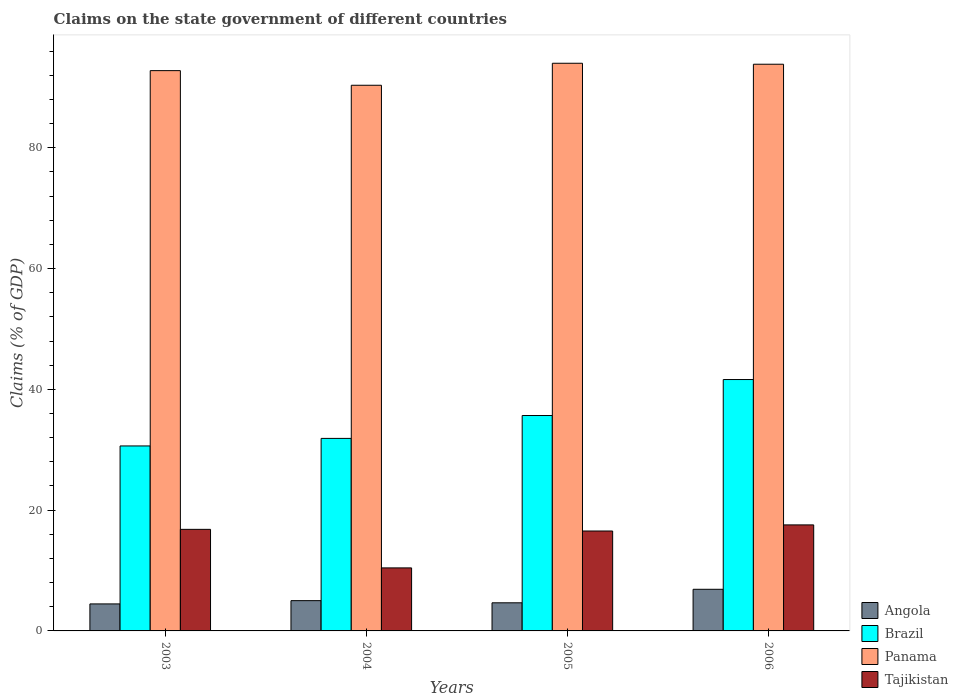Are the number of bars per tick equal to the number of legend labels?
Your response must be concise. Yes. Are the number of bars on each tick of the X-axis equal?
Give a very brief answer. Yes. In how many cases, is the number of bars for a given year not equal to the number of legend labels?
Give a very brief answer. 0. What is the percentage of GDP claimed on the state government in Panama in 2004?
Your answer should be very brief. 90.35. Across all years, what is the maximum percentage of GDP claimed on the state government in Brazil?
Provide a succinct answer. 41.63. Across all years, what is the minimum percentage of GDP claimed on the state government in Tajikistan?
Make the answer very short. 10.44. In which year was the percentage of GDP claimed on the state government in Angola maximum?
Offer a terse response. 2006. In which year was the percentage of GDP claimed on the state government in Panama minimum?
Provide a short and direct response. 2004. What is the total percentage of GDP claimed on the state government in Panama in the graph?
Your answer should be compact. 370.96. What is the difference between the percentage of GDP claimed on the state government in Tajikistan in 2003 and that in 2006?
Provide a succinct answer. -0.74. What is the difference between the percentage of GDP claimed on the state government in Brazil in 2006 and the percentage of GDP claimed on the state government in Angola in 2004?
Offer a very short reply. 36.61. What is the average percentage of GDP claimed on the state government in Panama per year?
Your response must be concise. 92.74. In the year 2003, what is the difference between the percentage of GDP claimed on the state government in Angola and percentage of GDP claimed on the state government in Brazil?
Provide a succinct answer. -26.16. In how many years, is the percentage of GDP claimed on the state government in Brazil greater than 76 %?
Offer a terse response. 0. What is the ratio of the percentage of GDP claimed on the state government in Brazil in 2004 to that in 2005?
Provide a short and direct response. 0.89. What is the difference between the highest and the second highest percentage of GDP claimed on the state government in Panama?
Your response must be concise. 0.16. What is the difference between the highest and the lowest percentage of GDP claimed on the state government in Panama?
Offer a very short reply. 3.64. In how many years, is the percentage of GDP claimed on the state government in Tajikistan greater than the average percentage of GDP claimed on the state government in Tajikistan taken over all years?
Provide a succinct answer. 3. Is it the case that in every year, the sum of the percentage of GDP claimed on the state government in Brazil and percentage of GDP claimed on the state government in Tajikistan is greater than the sum of percentage of GDP claimed on the state government in Panama and percentage of GDP claimed on the state government in Angola?
Your answer should be compact. No. What does the 3rd bar from the left in 2004 represents?
Your answer should be very brief. Panama. Are all the bars in the graph horizontal?
Your answer should be compact. No. Does the graph contain grids?
Make the answer very short. No. What is the title of the graph?
Give a very brief answer. Claims on the state government of different countries. What is the label or title of the Y-axis?
Your answer should be very brief. Claims (% of GDP). What is the Claims (% of GDP) of Angola in 2003?
Ensure brevity in your answer.  4.47. What is the Claims (% of GDP) in Brazil in 2003?
Make the answer very short. 30.63. What is the Claims (% of GDP) in Panama in 2003?
Your answer should be compact. 92.78. What is the Claims (% of GDP) in Tajikistan in 2003?
Your response must be concise. 16.82. What is the Claims (% of GDP) of Angola in 2004?
Your response must be concise. 5.01. What is the Claims (% of GDP) in Brazil in 2004?
Make the answer very short. 31.88. What is the Claims (% of GDP) in Panama in 2004?
Your answer should be very brief. 90.35. What is the Claims (% of GDP) of Tajikistan in 2004?
Provide a succinct answer. 10.44. What is the Claims (% of GDP) of Angola in 2005?
Give a very brief answer. 4.66. What is the Claims (% of GDP) of Brazil in 2005?
Offer a very short reply. 35.67. What is the Claims (% of GDP) in Panama in 2005?
Your response must be concise. 94. What is the Claims (% of GDP) of Tajikistan in 2005?
Ensure brevity in your answer.  16.54. What is the Claims (% of GDP) in Angola in 2006?
Your answer should be compact. 6.89. What is the Claims (% of GDP) of Brazil in 2006?
Provide a succinct answer. 41.63. What is the Claims (% of GDP) in Panama in 2006?
Offer a terse response. 93.84. What is the Claims (% of GDP) of Tajikistan in 2006?
Provide a short and direct response. 17.56. Across all years, what is the maximum Claims (% of GDP) in Angola?
Provide a succinct answer. 6.89. Across all years, what is the maximum Claims (% of GDP) in Brazil?
Offer a terse response. 41.63. Across all years, what is the maximum Claims (% of GDP) in Panama?
Your answer should be very brief. 94. Across all years, what is the maximum Claims (% of GDP) of Tajikistan?
Offer a terse response. 17.56. Across all years, what is the minimum Claims (% of GDP) in Angola?
Provide a short and direct response. 4.47. Across all years, what is the minimum Claims (% of GDP) of Brazil?
Offer a very short reply. 30.63. Across all years, what is the minimum Claims (% of GDP) of Panama?
Offer a terse response. 90.35. Across all years, what is the minimum Claims (% of GDP) of Tajikistan?
Make the answer very short. 10.44. What is the total Claims (% of GDP) of Angola in the graph?
Make the answer very short. 21.03. What is the total Claims (% of GDP) of Brazil in the graph?
Offer a terse response. 139.8. What is the total Claims (% of GDP) of Panama in the graph?
Offer a terse response. 370.96. What is the total Claims (% of GDP) of Tajikistan in the graph?
Make the answer very short. 61.35. What is the difference between the Claims (% of GDP) of Angola in 2003 and that in 2004?
Offer a very short reply. -0.54. What is the difference between the Claims (% of GDP) in Brazil in 2003 and that in 2004?
Offer a terse response. -1.25. What is the difference between the Claims (% of GDP) of Panama in 2003 and that in 2004?
Provide a succinct answer. 2.42. What is the difference between the Claims (% of GDP) of Tajikistan in 2003 and that in 2004?
Your response must be concise. 6.38. What is the difference between the Claims (% of GDP) of Angola in 2003 and that in 2005?
Your response must be concise. -0.18. What is the difference between the Claims (% of GDP) of Brazil in 2003 and that in 2005?
Your answer should be compact. -5.04. What is the difference between the Claims (% of GDP) in Panama in 2003 and that in 2005?
Make the answer very short. -1.22. What is the difference between the Claims (% of GDP) of Tajikistan in 2003 and that in 2005?
Give a very brief answer. 0.27. What is the difference between the Claims (% of GDP) in Angola in 2003 and that in 2006?
Give a very brief answer. -2.42. What is the difference between the Claims (% of GDP) in Brazil in 2003 and that in 2006?
Your answer should be compact. -11. What is the difference between the Claims (% of GDP) of Panama in 2003 and that in 2006?
Your response must be concise. -1.06. What is the difference between the Claims (% of GDP) in Tajikistan in 2003 and that in 2006?
Your answer should be compact. -0.74. What is the difference between the Claims (% of GDP) of Angola in 2004 and that in 2005?
Ensure brevity in your answer.  0.36. What is the difference between the Claims (% of GDP) in Brazil in 2004 and that in 2005?
Keep it short and to the point. -3.79. What is the difference between the Claims (% of GDP) in Panama in 2004 and that in 2005?
Make the answer very short. -3.64. What is the difference between the Claims (% of GDP) in Tajikistan in 2004 and that in 2005?
Your answer should be compact. -6.11. What is the difference between the Claims (% of GDP) of Angola in 2004 and that in 2006?
Your response must be concise. -1.88. What is the difference between the Claims (% of GDP) in Brazil in 2004 and that in 2006?
Give a very brief answer. -9.75. What is the difference between the Claims (% of GDP) of Panama in 2004 and that in 2006?
Keep it short and to the point. -3.48. What is the difference between the Claims (% of GDP) of Tajikistan in 2004 and that in 2006?
Your answer should be compact. -7.12. What is the difference between the Claims (% of GDP) of Angola in 2005 and that in 2006?
Give a very brief answer. -2.24. What is the difference between the Claims (% of GDP) in Brazil in 2005 and that in 2006?
Ensure brevity in your answer.  -5.96. What is the difference between the Claims (% of GDP) of Panama in 2005 and that in 2006?
Keep it short and to the point. 0.16. What is the difference between the Claims (% of GDP) of Tajikistan in 2005 and that in 2006?
Provide a succinct answer. -1.01. What is the difference between the Claims (% of GDP) in Angola in 2003 and the Claims (% of GDP) in Brazil in 2004?
Your answer should be compact. -27.41. What is the difference between the Claims (% of GDP) of Angola in 2003 and the Claims (% of GDP) of Panama in 2004?
Offer a very short reply. -85.88. What is the difference between the Claims (% of GDP) in Angola in 2003 and the Claims (% of GDP) in Tajikistan in 2004?
Offer a very short reply. -5.96. What is the difference between the Claims (% of GDP) of Brazil in 2003 and the Claims (% of GDP) of Panama in 2004?
Provide a succinct answer. -59.72. What is the difference between the Claims (% of GDP) of Brazil in 2003 and the Claims (% of GDP) of Tajikistan in 2004?
Make the answer very short. 20.19. What is the difference between the Claims (% of GDP) in Panama in 2003 and the Claims (% of GDP) in Tajikistan in 2004?
Offer a very short reply. 82.34. What is the difference between the Claims (% of GDP) of Angola in 2003 and the Claims (% of GDP) of Brazil in 2005?
Provide a short and direct response. -31.19. What is the difference between the Claims (% of GDP) of Angola in 2003 and the Claims (% of GDP) of Panama in 2005?
Keep it short and to the point. -89.53. What is the difference between the Claims (% of GDP) in Angola in 2003 and the Claims (% of GDP) in Tajikistan in 2005?
Keep it short and to the point. -12.07. What is the difference between the Claims (% of GDP) of Brazil in 2003 and the Claims (% of GDP) of Panama in 2005?
Your answer should be very brief. -63.37. What is the difference between the Claims (% of GDP) in Brazil in 2003 and the Claims (% of GDP) in Tajikistan in 2005?
Offer a very short reply. 14.09. What is the difference between the Claims (% of GDP) of Panama in 2003 and the Claims (% of GDP) of Tajikistan in 2005?
Offer a terse response. 76.23. What is the difference between the Claims (% of GDP) of Angola in 2003 and the Claims (% of GDP) of Brazil in 2006?
Offer a terse response. -37.15. What is the difference between the Claims (% of GDP) in Angola in 2003 and the Claims (% of GDP) in Panama in 2006?
Offer a terse response. -89.36. What is the difference between the Claims (% of GDP) of Angola in 2003 and the Claims (% of GDP) of Tajikistan in 2006?
Make the answer very short. -13.08. What is the difference between the Claims (% of GDP) in Brazil in 2003 and the Claims (% of GDP) in Panama in 2006?
Offer a terse response. -63.21. What is the difference between the Claims (% of GDP) of Brazil in 2003 and the Claims (% of GDP) of Tajikistan in 2006?
Provide a short and direct response. 13.07. What is the difference between the Claims (% of GDP) in Panama in 2003 and the Claims (% of GDP) in Tajikistan in 2006?
Give a very brief answer. 75.22. What is the difference between the Claims (% of GDP) in Angola in 2004 and the Claims (% of GDP) in Brazil in 2005?
Make the answer very short. -30.65. What is the difference between the Claims (% of GDP) in Angola in 2004 and the Claims (% of GDP) in Panama in 2005?
Give a very brief answer. -88.98. What is the difference between the Claims (% of GDP) in Angola in 2004 and the Claims (% of GDP) in Tajikistan in 2005?
Your answer should be very brief. -11.53. What is the difference between the Claims (% of GDP) of Brazil in 2004 and the Claims (% of GDP) of Panama in 2005?
Give a very brief answer. -62.12. What is the difference between the Claims (% of GDP) of Brazil in 2004 and the Claims (% of GDP) of Tajikistan in 2005?
Keep it short and to the point. 15.34. What is the difference between the Claims (% of GDP) in Panama in 2004 and the Claims (% of GDP) in Tajikistan in 2005?
Give a very brief answer. 73.81. What is the difference between the Claims (% of GDP) in Angola in 2004 and the Claims (% of GDP) in Brazil in 2006?
Keep it short and to the point. -36.61. What is the difference between the Claims (% of GDP) in Angola in 2004 and the Claims (% of GDP) in Panama in 2006?
Your response must be concise. -88.82. What is the difference between the Claims (% of GDP) of Angola in 2004 and the Claims (% of GDP) of Tajikistan in 2006?
Make the answer very short. -12.54. What is the difference between the Claims (% of GDP) in Brazil in 2004 and the Claims (% of GDP) in Panama in 2006?
Provide a short and direct response. -61.96. What is the difference between the Claims (% of GDP) in Brazil in 2004 and the Claims (% of GDP) in Tajikistan in 2006?
Keep it short and to the point. 14.32. What is the difference between the Claims (% of GDP) of Panama in 2004 and the Claims (% of GDP) of Tajikistan in 2006?
Provide a succinct answer. 72.8. What is the difference between the Claims (% of GDP) of Angola in 2005 and the Claims (% of GDP) of Brazil in 2006?
Your answer should be very brief. -36.97. What is the difference between the Claims (% of GDP) in Angola in 2005 and the Claims (% of GDP) in Panama in 2006?
Provide a short and direct response. -89.18. What is the difference between the Claims (% of GDP) of Angola in 2005 and the Claims (% of GDP) of Tajikistan in 2006?
Make the answer very short. -12.9. What is the difference between the Claims (% of GDP) in Brazil in 2005 and the Claims (% of GDP) in Panama in 2006?
Provide a succinct answer. -58.17. What is the difference between the Claims (% of GDP) of Brazil in 2005 and the Claims (% of GDP) of Tajikistan in 2006?
Your response must be concise. 18.11. What is the difference between the Claims (% of GDP) of Panama in 2005 and the Claims (% of GDP) of Tajikistan in 2006?
Keep it short and to the point. 76.44. What is the average Claims (% of GDP) in Angola per year?
Keep it short and to the point. 5.26. What is the average Claims (% of GDP) in Brazil per year?
Keep it short and to the point. 34.95. What is the average Claims (% of GDP) of Panama per year?
Provide a short and direct response. 92.74. What is the average Claims (% of GDP) of Tajikistan per year?
Your answer should be compact. 15.34. In the year 2003, what is the difference between the Claims (% of GDP) of Angola and Claims (% of GDP) of Brazil?
Provide a succinct answer. -26.16. In the year 2003, what is the difference between the Claims (% of GDP) in Angola and Claims (% of GDP) in Panama?
Offer a terse response. -88.3. In the year 2003, what is the difference between the Claims (% of GDP) of Angola and Claims (% of GDP) of Tajikistan?
Your answer should be compact. -12.35. In the year 2003, what is the difference between the Claims (% of GDP) of Brazil and Claims (% of GDP) of Panama?
Ensure brevity in your answer.  -62.15. In the year 2003, what is the difference between the Claims (% of GDP) of Brazil and Claims (% of GDP) of Tajikistan?
Offer a very short reply. 13.81. In the year 2003, what is the difference between the Claims (% of GDP) of Panama and Claims (% of GDP) of Tajikistan?
Your answer should be compact. 75.96. In the year 2004, what is the difference between the Claims (% of GDP) of Angola and Claims (% of GDP) of Brazil?
Give a very brief answer. -26.87. In the year 2004, what is the difference between the Claims (% of GDP) in Angola and Claims (% of GDP) in Panama?
Make the answer very short. -85.34. In the year 2004, what is the difference between the Claims (% of GDP) in Angola and Claims (% of GDP) in Tajikistan?
Your answer should be compact. -5.42. In the year 2004, what is the difference between the Claims (% of GDP) in Brazil and Claims (% of GDP) in Panama?
Offer a very short reply. -58.47. In the year 2004, what is the difference between the Claims (% of GDP) in Brazil and Claims (% of GDP) in Tajikistan?
Your answer should be very brief. 21.44. In the year 2004, what is the difference between the Claims (% of GDP) of Panama and Claims (% of GDP) of Tajikistan?
Keep it short and to the point. 79.92. In the year 2005, what is the difference between the Claims (% of GDP) in Angola and Claims (% of GDP) in Brazil?
Provide a succinct answer. -31.01. In the year 2005, what is the difference between the Claims (% of GDP) in Angola and Claims (% of GDP) in Panama?
Your answer should be compact. -89.34. In the year 2005, what is the difference between the Claims (% of GDP) of Angola and Claims (% of GDP) of Tajikistan?
Ensure brevity in your answer.  -11.89. In the year 2005, what is the difference between the Claims (% of GDP) of Brazil and Claims (% of GDP) of Panama?
Your answer should be compact. -58.33. In the year 2005, what is the difference between the Claims (% of GDP) in Brazil and Claims (% of GDP) in Tajikistan?
Your answer should be very brief. 19.12. In the year 2005, what is the difference between the Claims (% of GDP) of Panama and Claims (% of GDP) of Tajikistan?
Your response must be concise. 77.45. In the year 2006, what is the difference between the Claims (% of GDP) in Angola and Claims (% of GDP) in Brazil?
Make the answer very short. -34.73. In the year 2006, what is the difference between the Claims (% of GDP) of Angola and Claims (% of GDP) of Panama?
Make the answer very short. -86.94. In the year 2006, what is the difference between the Claims (% of GDP) in Angola and Claims (% of GDP) in Tajikistan?
Provide a succinct answer. -10.66. In the year 2006, what is the difference between the Claims (% of GDP) in Brazil and Claims (% of GDP) in Panama?
Provide a short and direct response. -52.21. In the year 2006, what is the difference between the Claims (% of GDP) of Brazil and Claims (% of GDP) of Tajikistan?
Your answer should be very brief. 24.07. In the year 2006, what is the difference between the Claims (% of GDP) of Panama and Claims (% of GDP) of Tajikistan?
Offer a terse response. 76.28. What is the ratio of the Claims (% of GDP) in Angola in 2003 to that in 2004?
Your answer should be very brief. 0.89. What is the ratio of the Claims (% of GDP) in Brazil in 2003 to that in 2004?
Offer a terse response. 0.96. What is the ratio of the Claims (% of GDP) in Panama in 2003 to that in 2004?
Keep it short and to the point. 1.03. What is the ratio of the Claims (% of GDP) of Tajikistan in 2003 to that in 2004?
Offer a very short reply. 1.61. What is the ratio of the Claims (% of GDP) of Angola in 2003 to that in 2005?
Make the answer very short. 0.96. What is the ratio of the Claims (% of GDP) in Brazil in 2003 to that in 2005?
Your answer should be very brief. 0.86. What is the ratio of the Claims (% of GDP) of Tajikistan in 2003 to that in 2005?
Your answer should be very brief. 1.02. What is the ratio of the Claims (% of GDP) of Angola in 2003 to that in 2006?
Your answer should be compact. 0.65. What is the ratio of the Claims (% of GDP) of Brazil in 2003 to that in 2006?
Offer a very short reply. 0.74. What is the ratio of the Claims (% of GDP) in Panama in 2003 to that in 2006?
Offer a terse response. 0.99. What is the ratio of the Claims (% of GDP) in Tajikistan in 2003 to that in 2006?
Ensure brevity in your answer.  0.96. What is the ratio of the Claims (% of GDP) in Angola in 2004 to that in 2005?
Offer a terse response. 1.08. What is the ratio of the Claims (% of GDP) of Brazil in 2004 to that in 2005?
Your answer should be very brief. 0.89. What is the ratio of the Claims (% of GDP) in Panama in 2004 to that in 2005?
Provide a succinct answer. 0.96. What is the ratio of the Claims (% of GDP) in Tajikistan in 2004 to that in 2005?
Your response must be concise. 0.63. What is the ratio of the Claims (% of GDP) in Angola in 2004 to that in 2006?
Your answer should be compact. 0.73. What is the ratio of the Claims (% of GDP) in Brazil in 2004 to that in 2006?
Provide a short and direct response. 0.77. What is the ratio of the Claims (% of GDP) of Panama in 2004 to that in 2006?
Your response must be concise. 0.96. What is the ratio of the Claims (% of GDP) of Tajikistan in 2004 to that in 2006?
Ensure brevity in your answer.  0.59. What is the ratio of the Claims (% of GDP) of Angola in 2005 to that in 2006?
Give a very brief answer. 0.68. What is the ratio of the Claims (% of GDP) in Brazil in 2005 to that in 2006?
Your answer should be very brief. 0.86. What is the ratio of the Claims (% of GDP) in Panama in 2005 to that in 2006?
Your answer should be very brief. 1. What is the ratio of the Claims (% of GDP) in Tajikistan in 2005 to that in 2006?
Make the answer very short. 0.94. What is the difference between the highest and the second highest Claims (% of GDP) of Angola?
Provide a short and direct response. 1.88. What is the difference between the highest and the second highest Claims (% of GDP) of Brazil?
Make the answer very short. 5.96. What is the difference between the highest and the second highest Claims (% of GDP) in Panama?
Your answer should be very brief. 0.16. What is the difference between the highest and the second highest Claims (% of GDP) in Tajikistan?
Offer a very short reply. 0.74. What is the difference between the highest and the lowest Claims (% of GDP) of Angola?
Your answer should be very brief. 2.42. What is the difference between the highest and the lowest Claims (% of GDP) in Brazil?
Your response must be concise. 11. What is the difference between the highest and the lowest Claims (% of GDP) in Panama?
Provide a succinct answer. 3.64. What is the difference between the highest and the lowest Claims (% of GDP) in Tajikistan?
Your answer should be very brief. 7.12. 